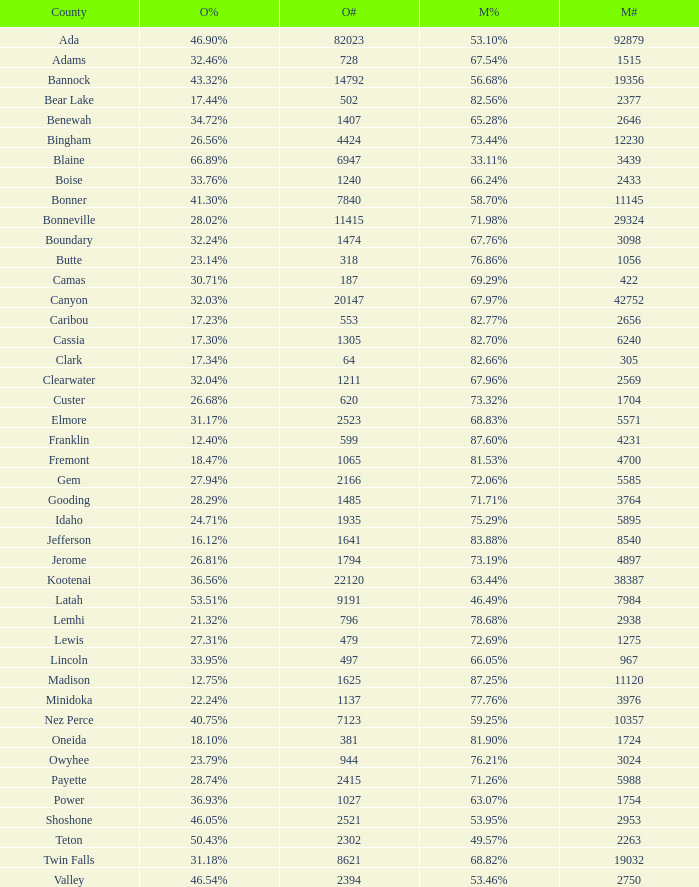For Gem County, what was the Obama vote percentage? 27.94%. 